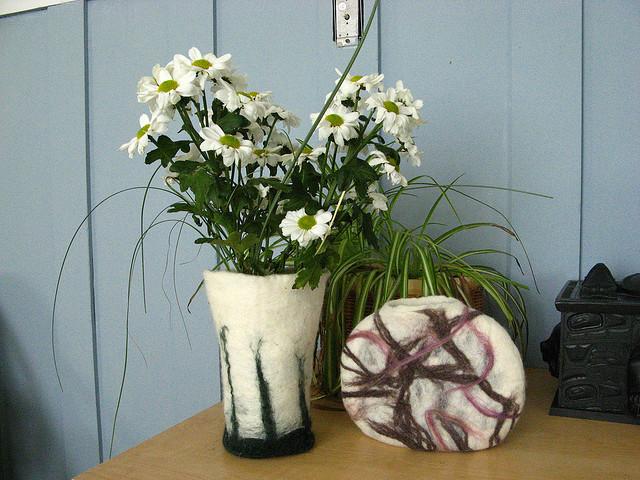What is the difference between the material on the wall and on the artwork?
Give a very brief answer. Color. Is there any broccoli in the picture?
Quick response, please. No. What color is the wall?
Concise answer only. Blue. What type of plant is it?
Short answer required. Daisy. What kind of flowers are in the vase?
Quick response, please. Daisies. What type of flowers are in the picture?
Give a very brief answer. Daisies. Would deer eat these things?
Answer briefly. Yes. 